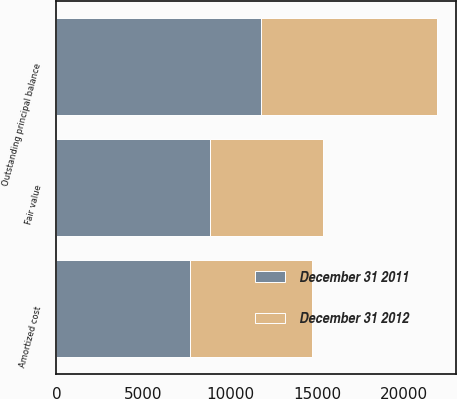Convert chart to OTSL. <chart><loc_0><loc_0><loc_500><loc_500><stacked_bar_chart><ecel><fcel>Outstanding principal balance<fcel>Amortized cost<fcel>Fair value<nl><fcel>December 31 2011<fcel>11791<fcel>7718<fcel>8823<nl><fcel>December 31 2012<fcel>10119<fcel>7006<fcel>6535<nl></chart> 